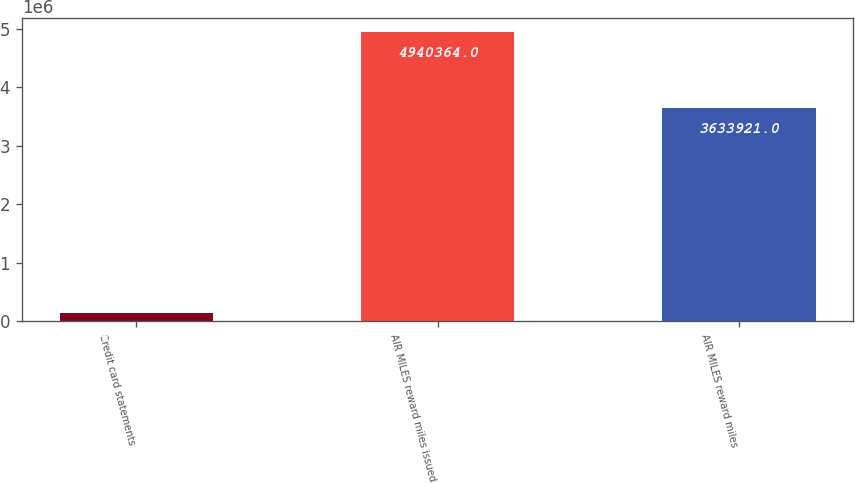Convert chart. <chart><loc_0><loc_0><loc_500><loc_500><bar_chart><fcel>Credit card statements<fcel>AIR MILES reward miles issued<fcel>AIR MILES reward miles<nl><fcel>142064<fcel>4.94036e+06<fcel>3.63392e+06<nl></chart> 